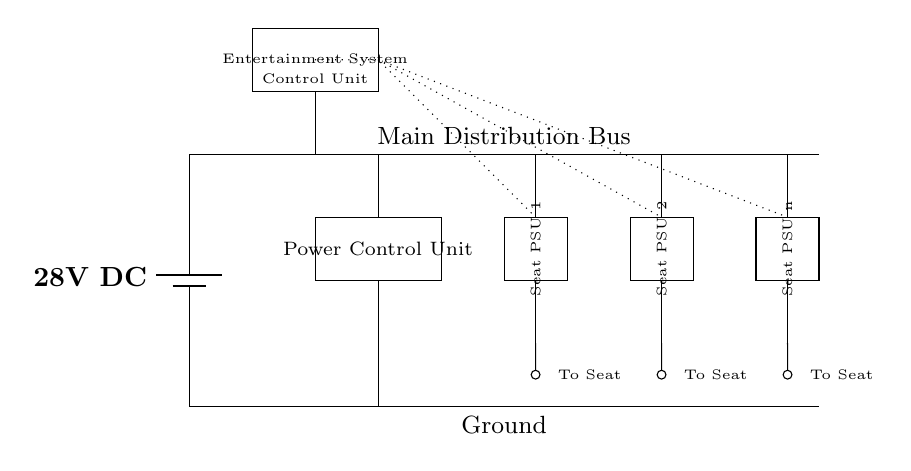What is the main voltage supply of the circuit? The voltage supply of the circuit is indicated at the battery component, which is labeled as 28V DC.
Answer: 28V DC What are the components connected to the main distribution bus? The main distribution bus connects to the Power Control Unit and several Seat Power Supply Units, allowing power to be distributed to each of these components.
Answer: Power Control Unit, Seat PSU 1, Seat PSU 2, Seat PSU n How many Seat Power Supply Units are depicted in the circuit? The circuit shows three distinct Seat Power Supply Units, each labeled consecutively, indicating their existence within the system.
Answer: Three What is the function of the Power Control Unit? The Power Control Unit regulates and manages the distribution of power from the main supply to the connected components, such as the Seat Power Supply Units.
Answer: Regulation Which component controls the Entertainment System? The Entertainment System is controlled by the Entertainment System Control Unit, which manages the signals and power flow towards the system.
Answer: Entertainment System Control Unit What type of signals are indicated by the dotted lines? The dotted lines represent control signals that connect the Entertainment System Control Unit to the Seat Power Supply Units, indicating the control mechanism between them.
Answer: Control signals What does the term "PSU" stand for in the circuit diagram? "PSU" stands for Power Supply Unit, which is responsible for supplying power to specific components, in this case, individual seats in the aircraft.
Answer: Power Supply Unit 